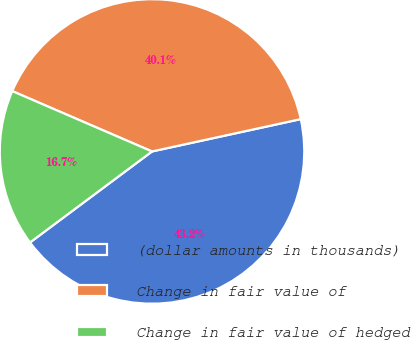Convert chart to OTSL. <chart><loc_0><loc_0><loc_500><loc_500><pie_chart><fcel>(dollar amounts in thousands)<fcel>Change in fair value of<fcel>Change in fair value of hedged<nl><fcel>43.21%<fcel>40.11%<fcel>16.69%<nl></chart> 